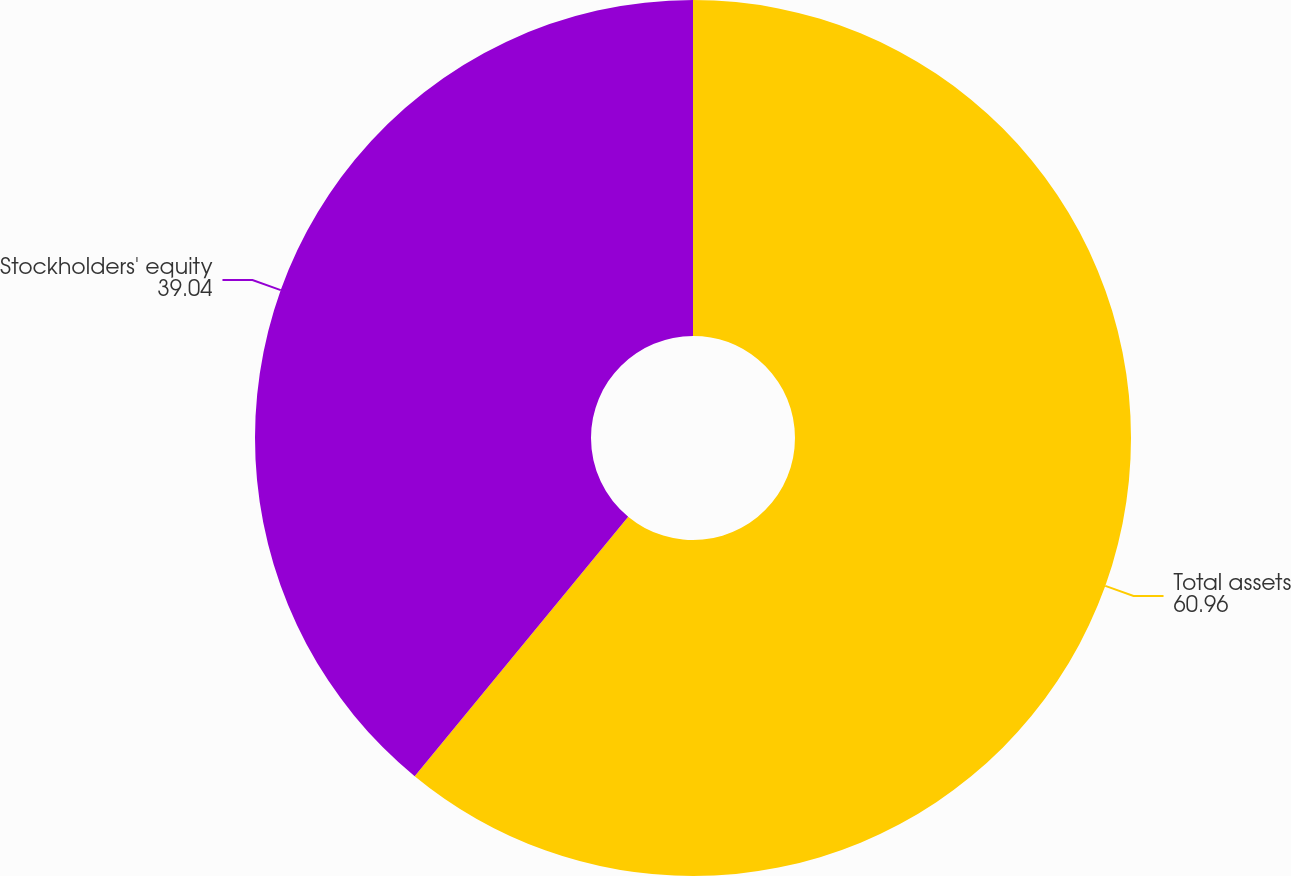Convert chart. <chart><loc_0><loc_0><loc_500><loc_500><pie_chart><fcel>Total assets<fcel>Stockholders' equity<nl><fcel>60.96%<fcel>39.04%<nl></chart> 